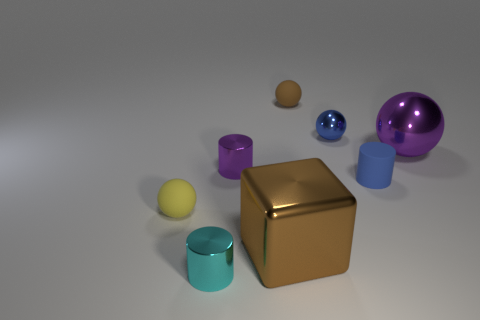What number of other small metal things are the same shape as the small cyan metallic object? There is one other object that shares the same cylindrical shape as the small cyan metallic object, which appears to be a purple metallic cylinder. 